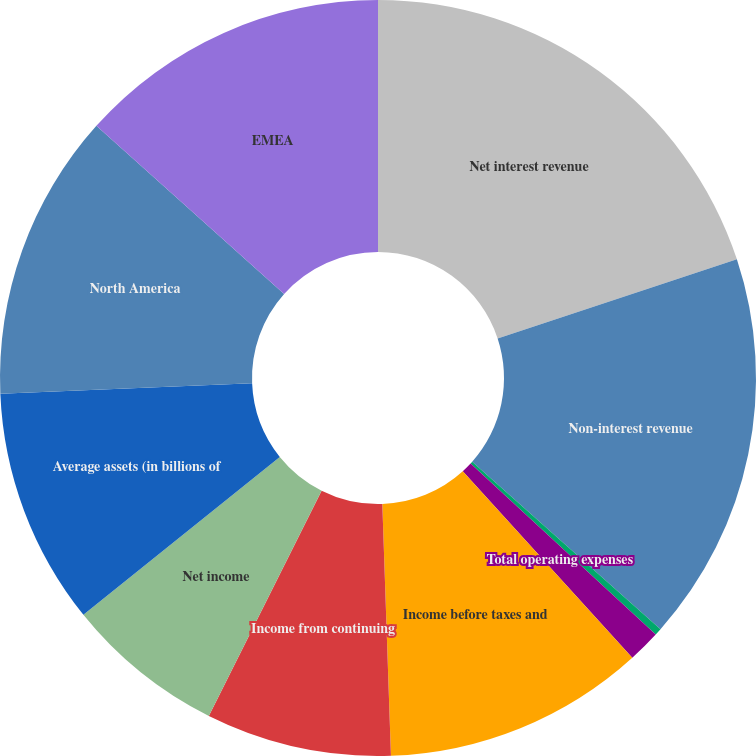Convert chart to OTSL. <chart><loc_0><loc_0><loc_500><loc_500><pie_chart><fcel>Net interest revenue<fcel>Non-interest revenue<fcel>Revenues net of interest<fcel>Total operating expenses<fcel>Income before taxes and<fcel>Income from continuing<fcel>Net income<fcel>Average assets (in billions of<fcel>North America<fcel>EMEA<nl><fcel>19.92%<fcel>16.65%<fcel>0.3%<fcel>1.39%<fcel>11.2%<fcel>7.93%<fcel>6.84%<fcel>10.11%<fcel>12.29%<fcel>13.38%<nl></chart> 